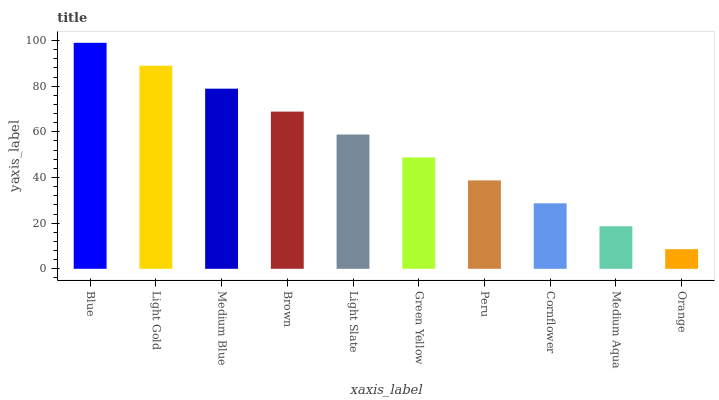Is Orange the minimum?
Answer yes or no. Yes. Is Blue the maximum?
Answer yes or no. Yes. Is Light Gold the minimum?
Answer yes or no. No. Is Light Gold the maximum?
Answer yes or no. No. Is Blue greater than Light Gold?
Answer yes or no. Yes. Is Light Gold less than Blue?
Answer yes or no. Yes. Is Light Gold greater than Blue?
Answer yes or no. No. Is Blue less than Light Gold?
Answer yes or no. No. Is Light Slate the high median?
Answer yes or no. Yes. Is Green Yellow the low median?
Answer yes or no. Yes. Is Blue the high median?
Answer yes or no. No. Is Medium Aqua the low median?
Answer yes or no. No. 